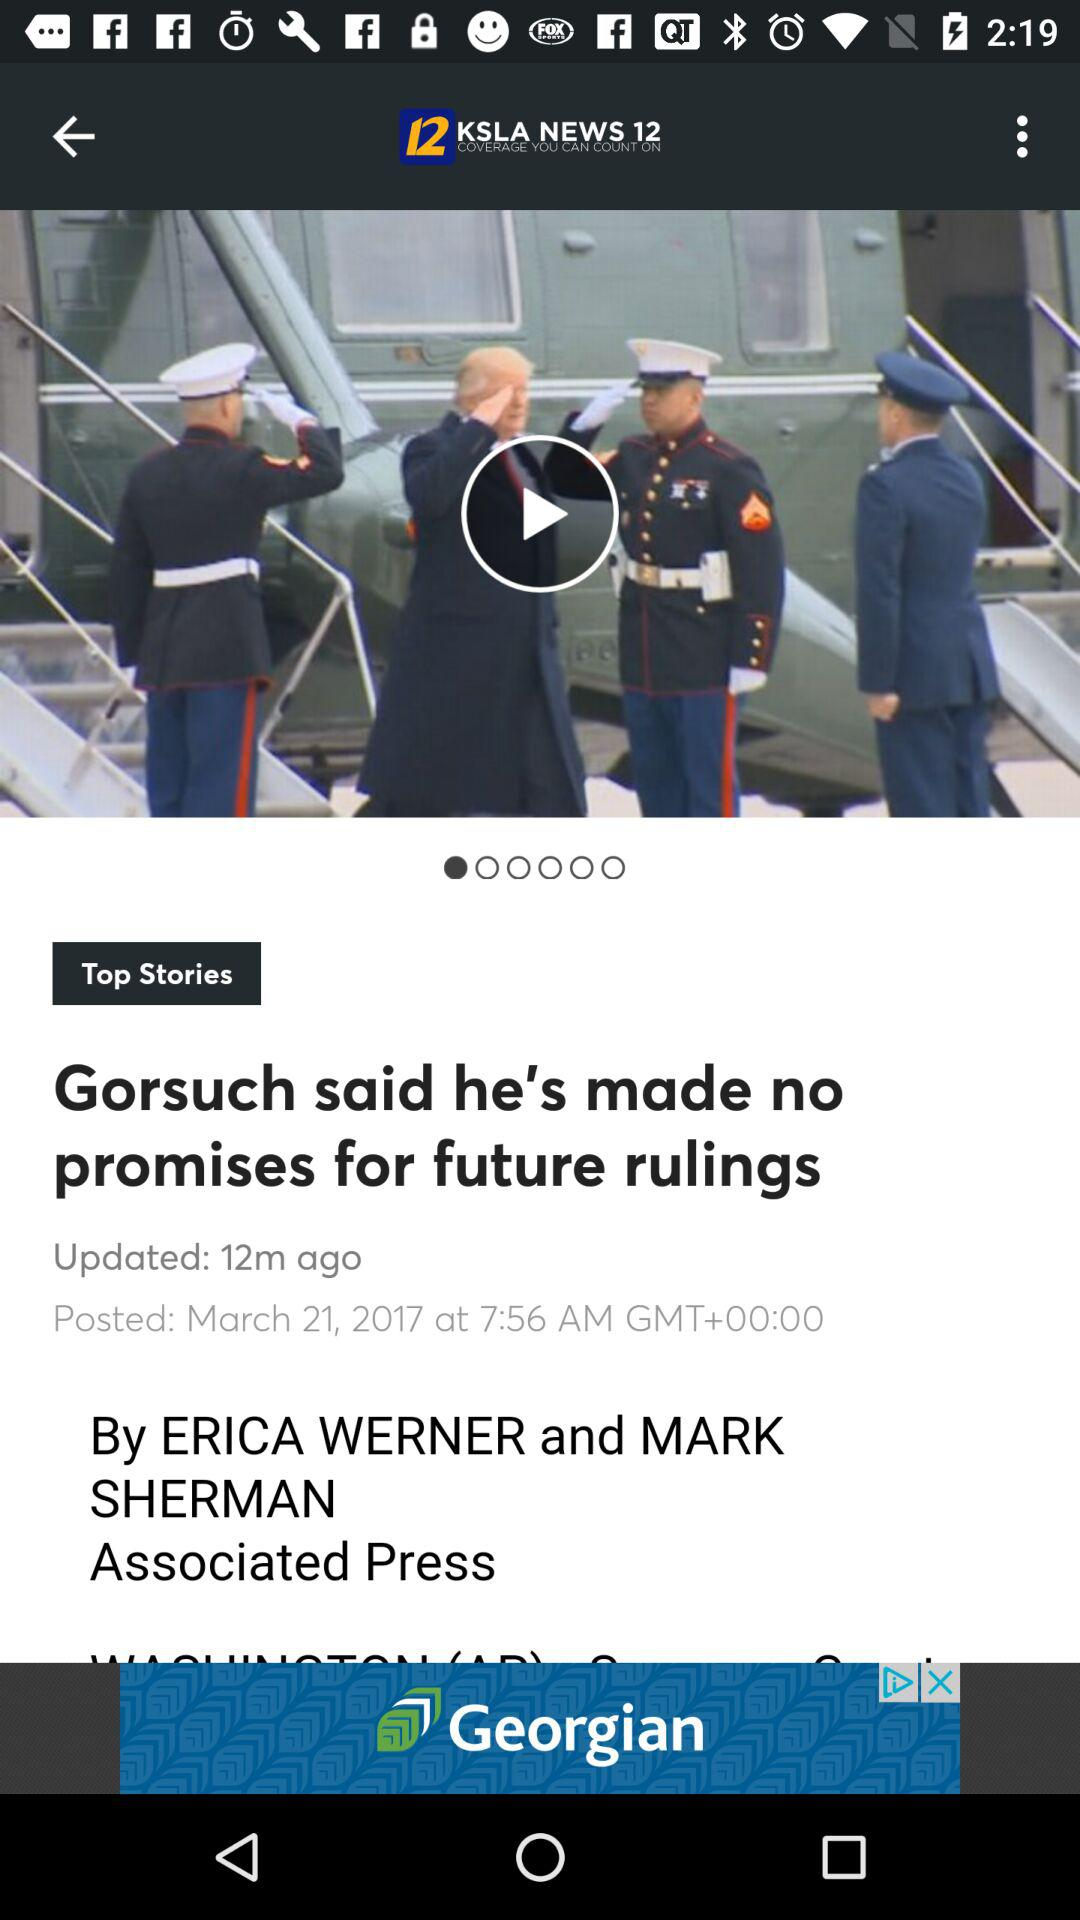What is the headline? The headline is "Gorsuch said he's made no promises for future rulings". 